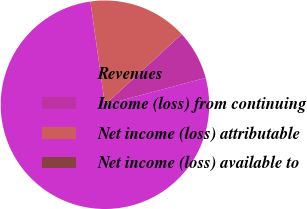Convert chart to OTSL. <chart><loc_0><loc_0><loc_500><loc_500><pie_chart><fcel>Revenues<fcel>Income (loss) from continuing<fcel>Net income (loss) attributable<fcel>Net income (loss) available to<nl><fcel>76.92%<fcel>7.69%<fcel>15.39%<fcel>0.0%<nl></chart> 